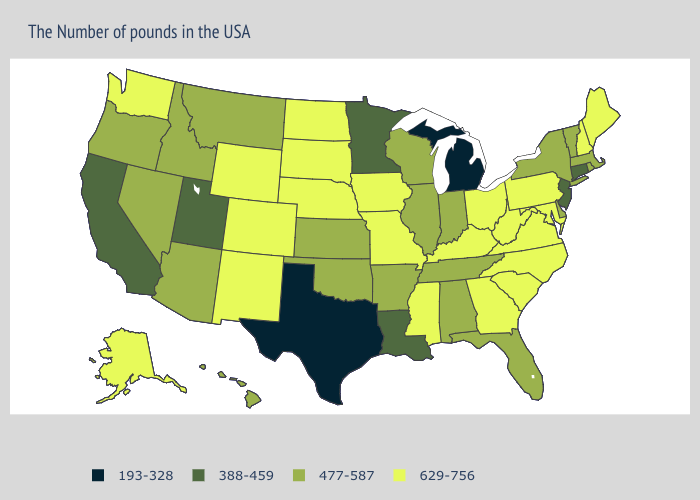What is the highest value in the USA?
Concise answer only. 629-756. Name the states that have a value in the range 477-587?
Keep it brief. Massachusetts, Rhode Island, Vermont, New York, Delaware, Florida, Indiana, Alabama, Tennessee, Wisconsin, Illinois, Arkansas, Kansas, Oklahoma, Montana, Arizona, Idaho, Nevada, Oregon, Hawaii. What is the highest value in states that border Delaware?
Be succinct. 629-756. What is the highest value in the West ?
Be succinct. 629-756. What is the highest value in the MidWest ?
Be succinct. 629-756. Among the states that border Georgia , which have the lowest value?
Answer briefly. Florida, Alabama, Tennessee. Which states have the lowest value in the West?
Quick response, please. Utah, California. Does West Virginia have the highest value in the USA?
Keep it brief. Yes. Does South Dakota have a higher value than Arizona?
Give a very brief answer. Yes. Does Oklahoma have the lowest value in the South?
Short answer required. No. Does Maryland have the same value as Ohio?
Give a very brief answer. Yes. Name the states that have a value in the range 477-587?
Keep it brief. Massachusetts, Rhode Island, Vermont, New York, Delaware, Florida, Indiana, Alabama, Tennessee, Wisconsin, Illinois, Arkansas, Kansas, Oklahoma, Montana, Arizona, Idaho, Nevada, Oregon, Hawaii. What is the value of Hawaii?
Be succinct. 477-587. What is the value of Montana?
Be succinct. 477-587. Name the states that have a value in the range 477-587?
Concise answer only. Massachusetts, Rhode Island, Vermont, New York, Delaware, Florida, Indiana, Alabama, Tennessee, Wisconsin, Illinois, Arkansas, Kansas, Oklahoma, Montana, Arizona, Idaho, Nevada, Oregon, Hawaii. 